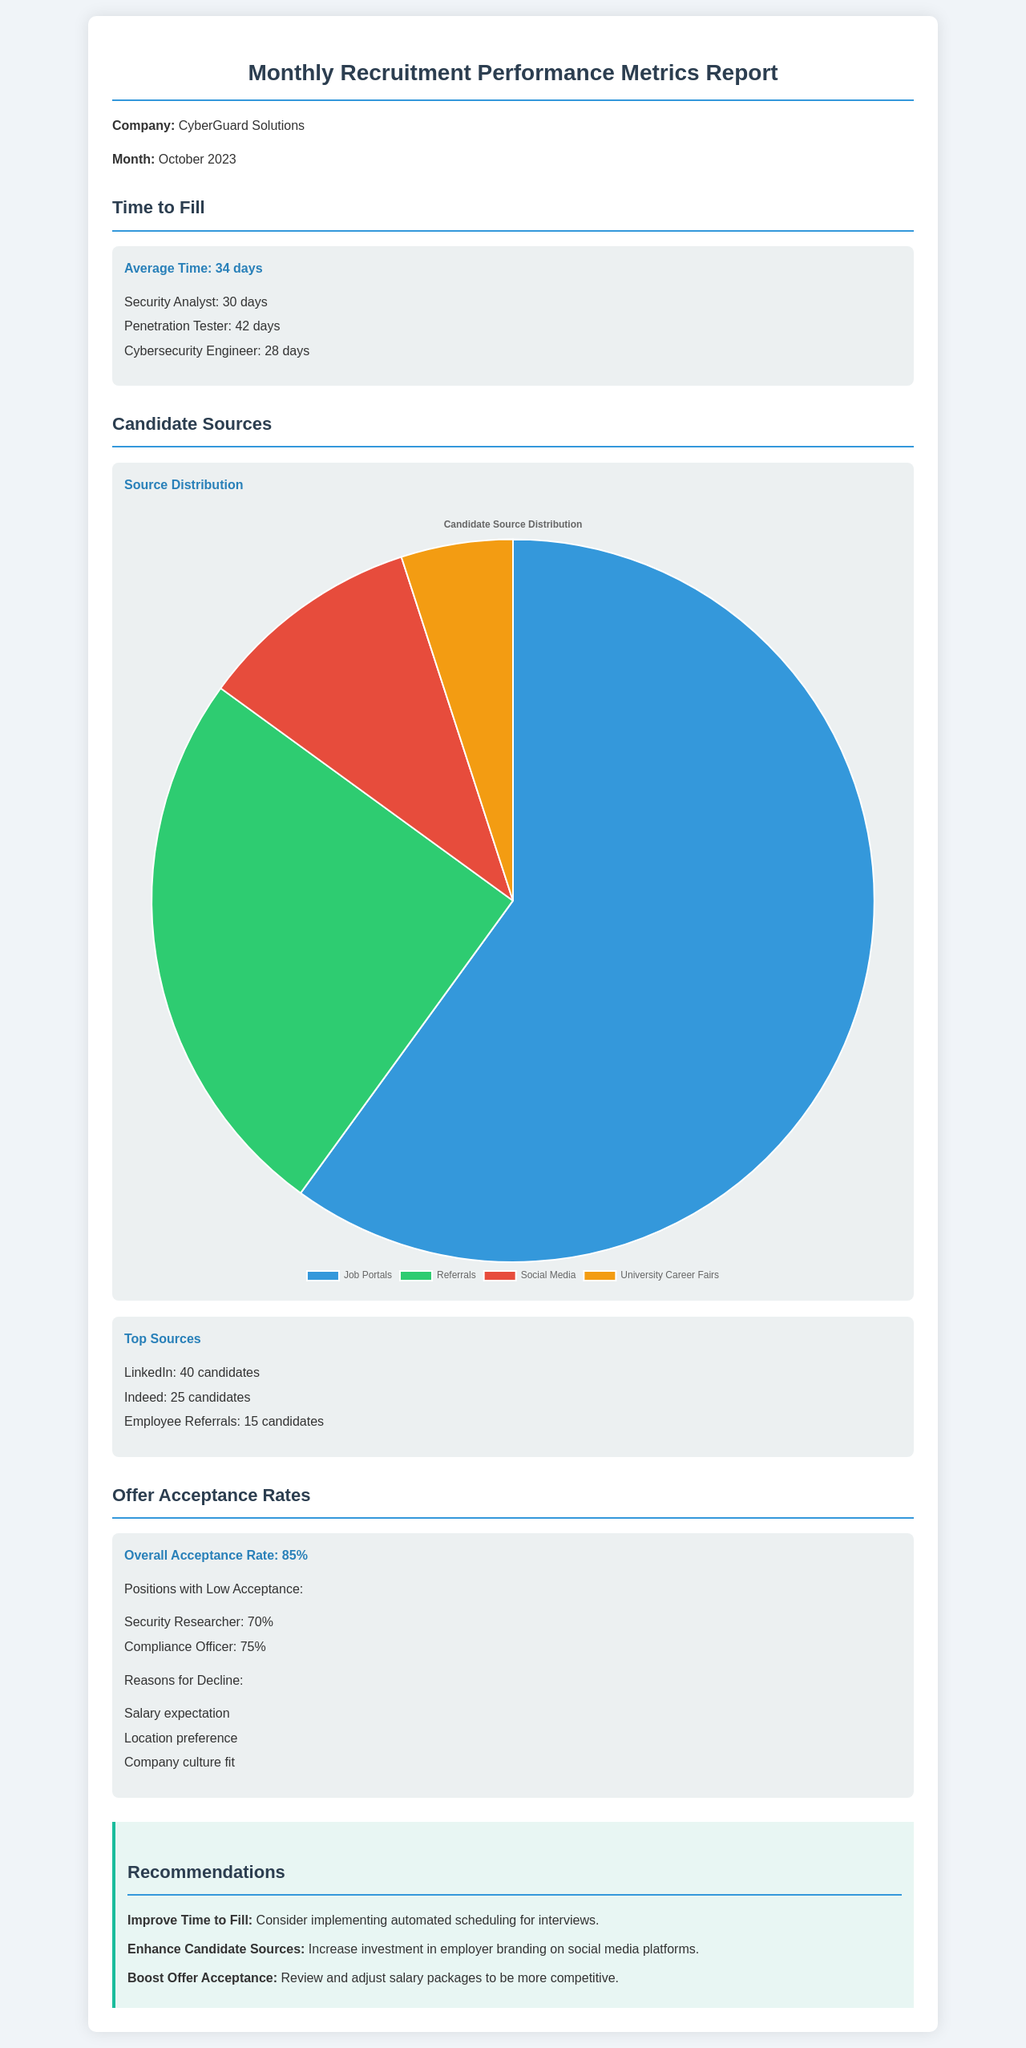What is the average time to fill for October 2023? The average time to fill is stated in the document, which is 34 days.
Answer: 34 days Which position took the longest to fill? The position that took the longest to fill is listed in the document as Penetration Tester, with a time of 42 days.
Answer: Penetration Tester How many candidates were sourced from LinkedIn? The number of candidates sourced from LinkedIn is mentioned in the document, which is 40 candidates.
Answer: 40 candidates What is the overall offer acceptance rate? The overall offer acceptance rate is provided in the document, which is 85%.
Answer: 85% What are two reasons for candidate declines? Two reasons cited in the document for candidate declines are salary expectation and location preference.
Answer: Salary expectation, location preference What metric failed to meet the acceptance rate benchmark? The positions with low acceptance rates are specified in the document as Security Researcher and Compliance Officer.
Answer: Security Researcher, Compliance Officer What is the highest candidate source category as shown in the chart? The highest candidate source category from the chart is Job Portals, which is represented with 60% of the candidates.
Answer: Job Portals What recommendation is made to enhance candidate sources? The recommendation given in the document is to increase investment in employer branding on social media platforms.
Answer: Increase investment in employer branding on social media platforms How many candidates were sourced from Employee Referrals? The document states that 15 candidates were sourced from Employee Referrals.
Answer: 15 candidates 